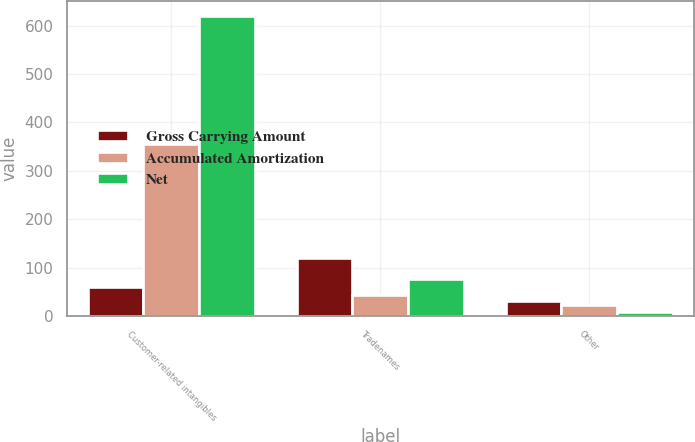Convert chart. <chart><loc_0><loc_0><loc_500><loc_500><stacked_bar_chart><ecel><fcel>Customer-related intangibles<fcel>Tradenames<fcel>Other<nl><fcel>Gross Carrying Amount<fcel>60<fcel>120<fcel>31<nl><fcel>Accumulated Amortization<fcel>355<fcel>44<fcel>23<nl><fcel>Net<fcel>619<fcel>76<fcel>8<nl></chart> 